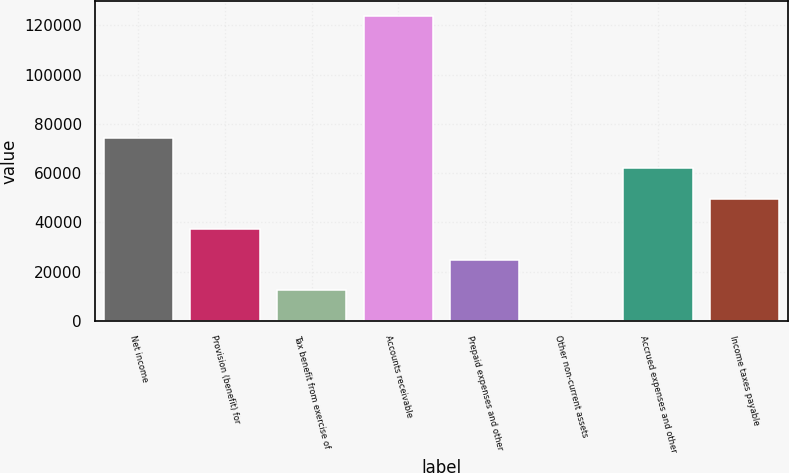Convert chart to OTSL. <chart><loc_0><loc_0><loc_500><loc_500><bar_chart><fcel>Net income<fcel>Provision (benefit) for<fcel>Tax benefit from exercise of<fcel>Accounts receivable<fcel>Prepaid expenses and other<fcel>Other non-current assets<fcel>Accrued expenses and other<fcel>Income taxes payable<nl><fcel>74266<fcel>37201<fcel>12491<fcel>123686<fcel>24846<fcel>136<fcel>61911<fcel>49556<nl></chart> 